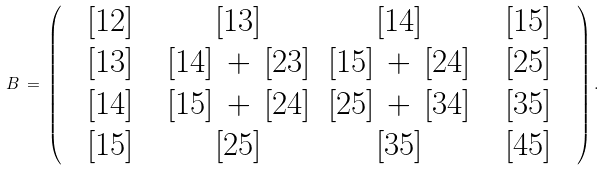Convert formula to latex. <formula><loc_0><loc_0><loc_500><loc_500>B \, = \, \left ( \begin{array} { c c c c c c c c } & [ 1 2 ] & & [ 1 3 ] & [ 1 4 ] & & [ 1 5 ] & \\ & [ 1 3 ] & & [ 1 4 ] \, + \, [ 2 3 ] & [ 1 5 ] \, + \, [ 2 4 ] & & [ 2 5 ] & \\ & [ 1 4 ] & & [ 1 5 ] \, + \, [ 2 4 ] & [ 2 5 ] \, + \, [ 3 4 ] & & [ 3 5 ] & \\ & [ 1 5 ] & & [ 2 5 ] & [ 3 5 ] & & [ 4 5 ] & \end{array} \right ) .</formula> 